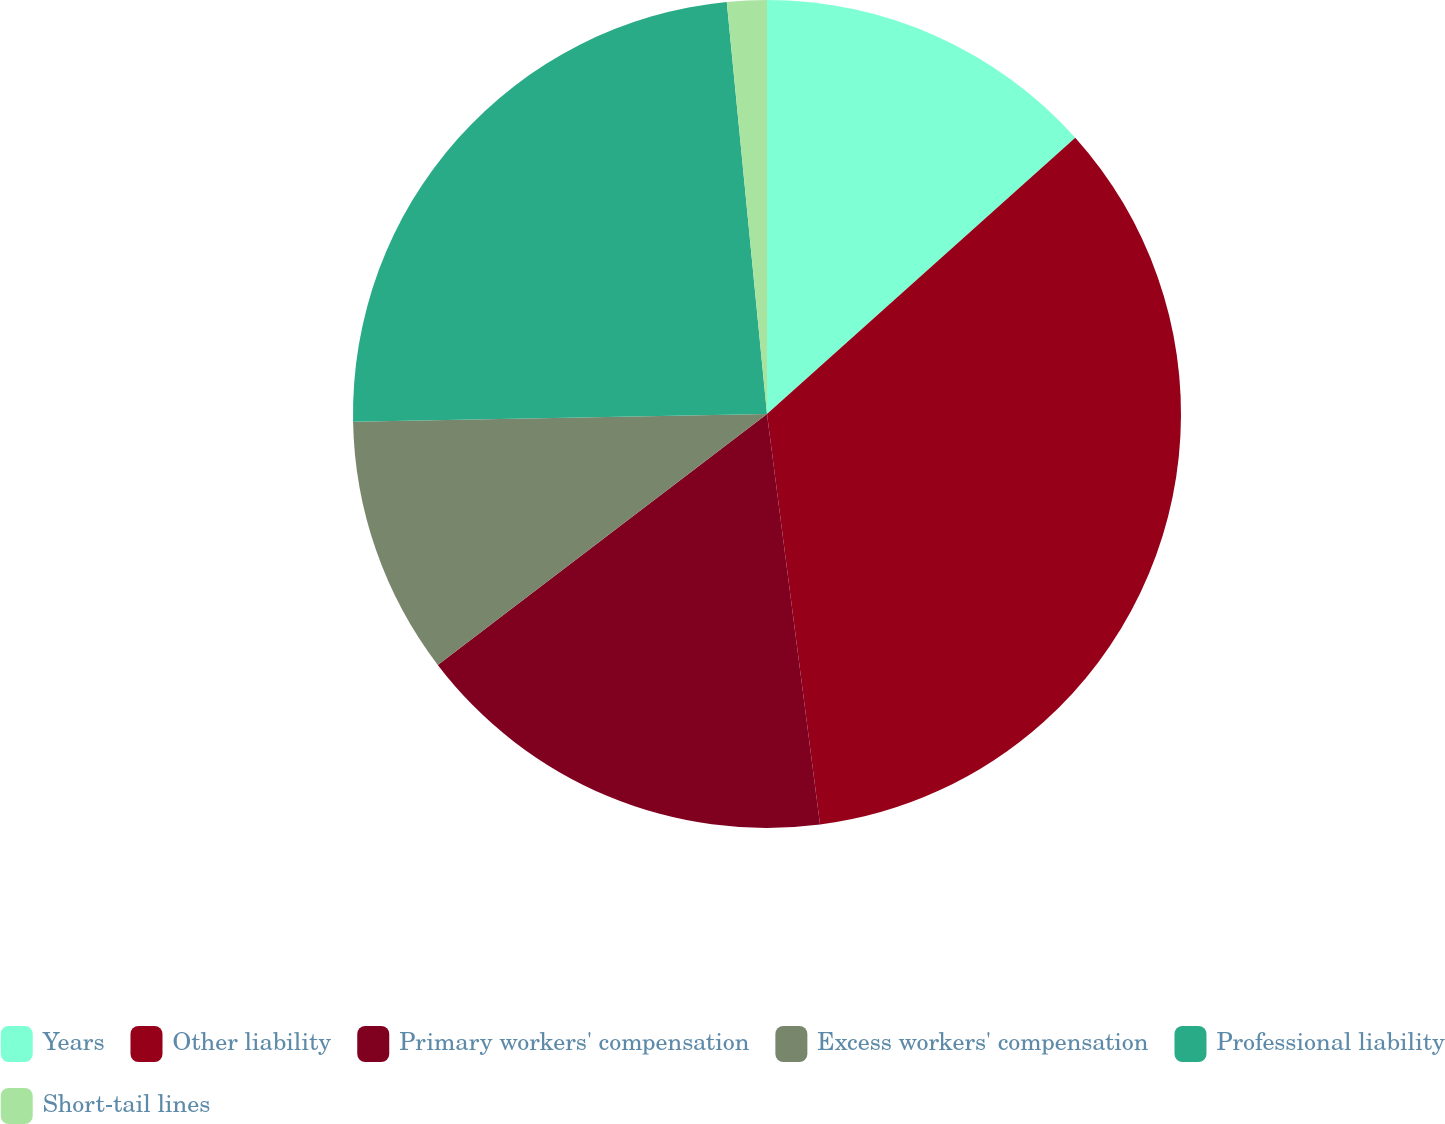Convert chart. <chart><loc_0><loc_0><loc_500><loc_500><pie_chart><fcel>Years<fcel>Other liability<fcel>Primary workers' compensation<fcel>Excess workers' compensation<fcel>Professional liability<fcel>Short-tail lines<nl><fcel>13.37%<fcel>34.59%<fcel>16.68%<fcel>10.07%<fcel>23.75%<fcel>1.55%<nl></chart> 